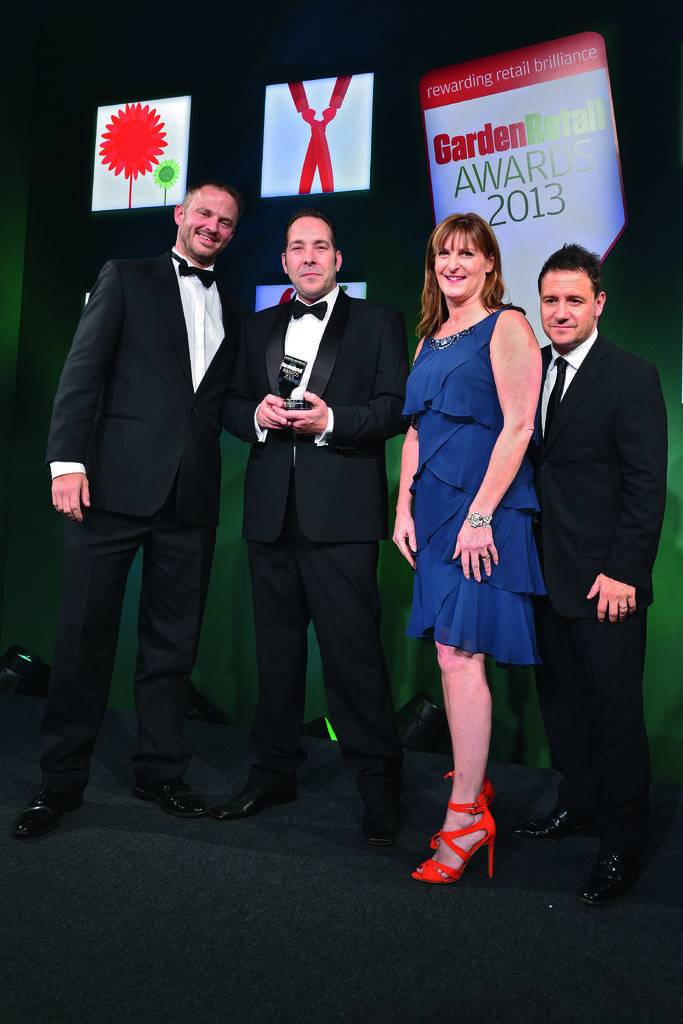Describe this image in one or two sentences. In this picture we can see three men and a woman standing on a platform and smiling and in the background we can see banners. 